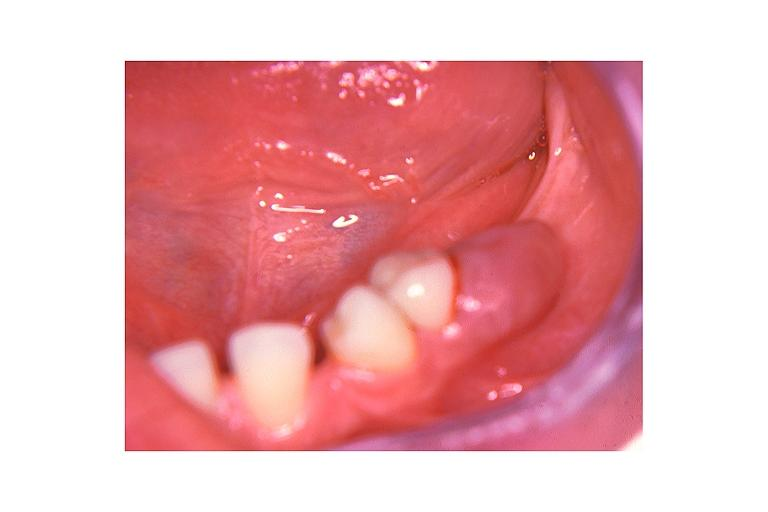does carcinoma superficial spreading show peripheral giant cell lesion?
Answer the question using a single word or phrase. No 